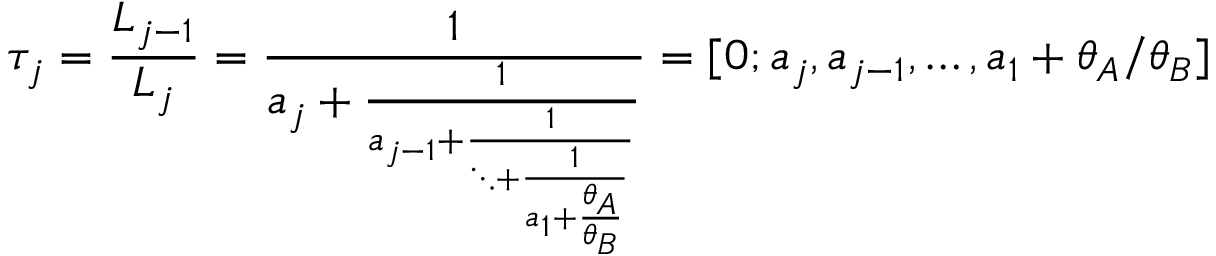<formula> <loc_0><loc_0><loc_500><loc_500>\tau _ { j } = \frac { L _ { j - 1 } } { L _ { j } } = \frac { 1 } { a _ { j } + \frac { 1 } { a _ { j - 1 } + \frac { 1 } { \ddots + \frac { 1 } { a _ { 1 } + \frac { \theta _ { A } } { \theta _ { B } } } } } } = [ 0 ; a _ { j } , a _ { j - 1 } , \dots , a _ { 1 } + \theta _ { A } / \theta _ { B } ]</formula> 